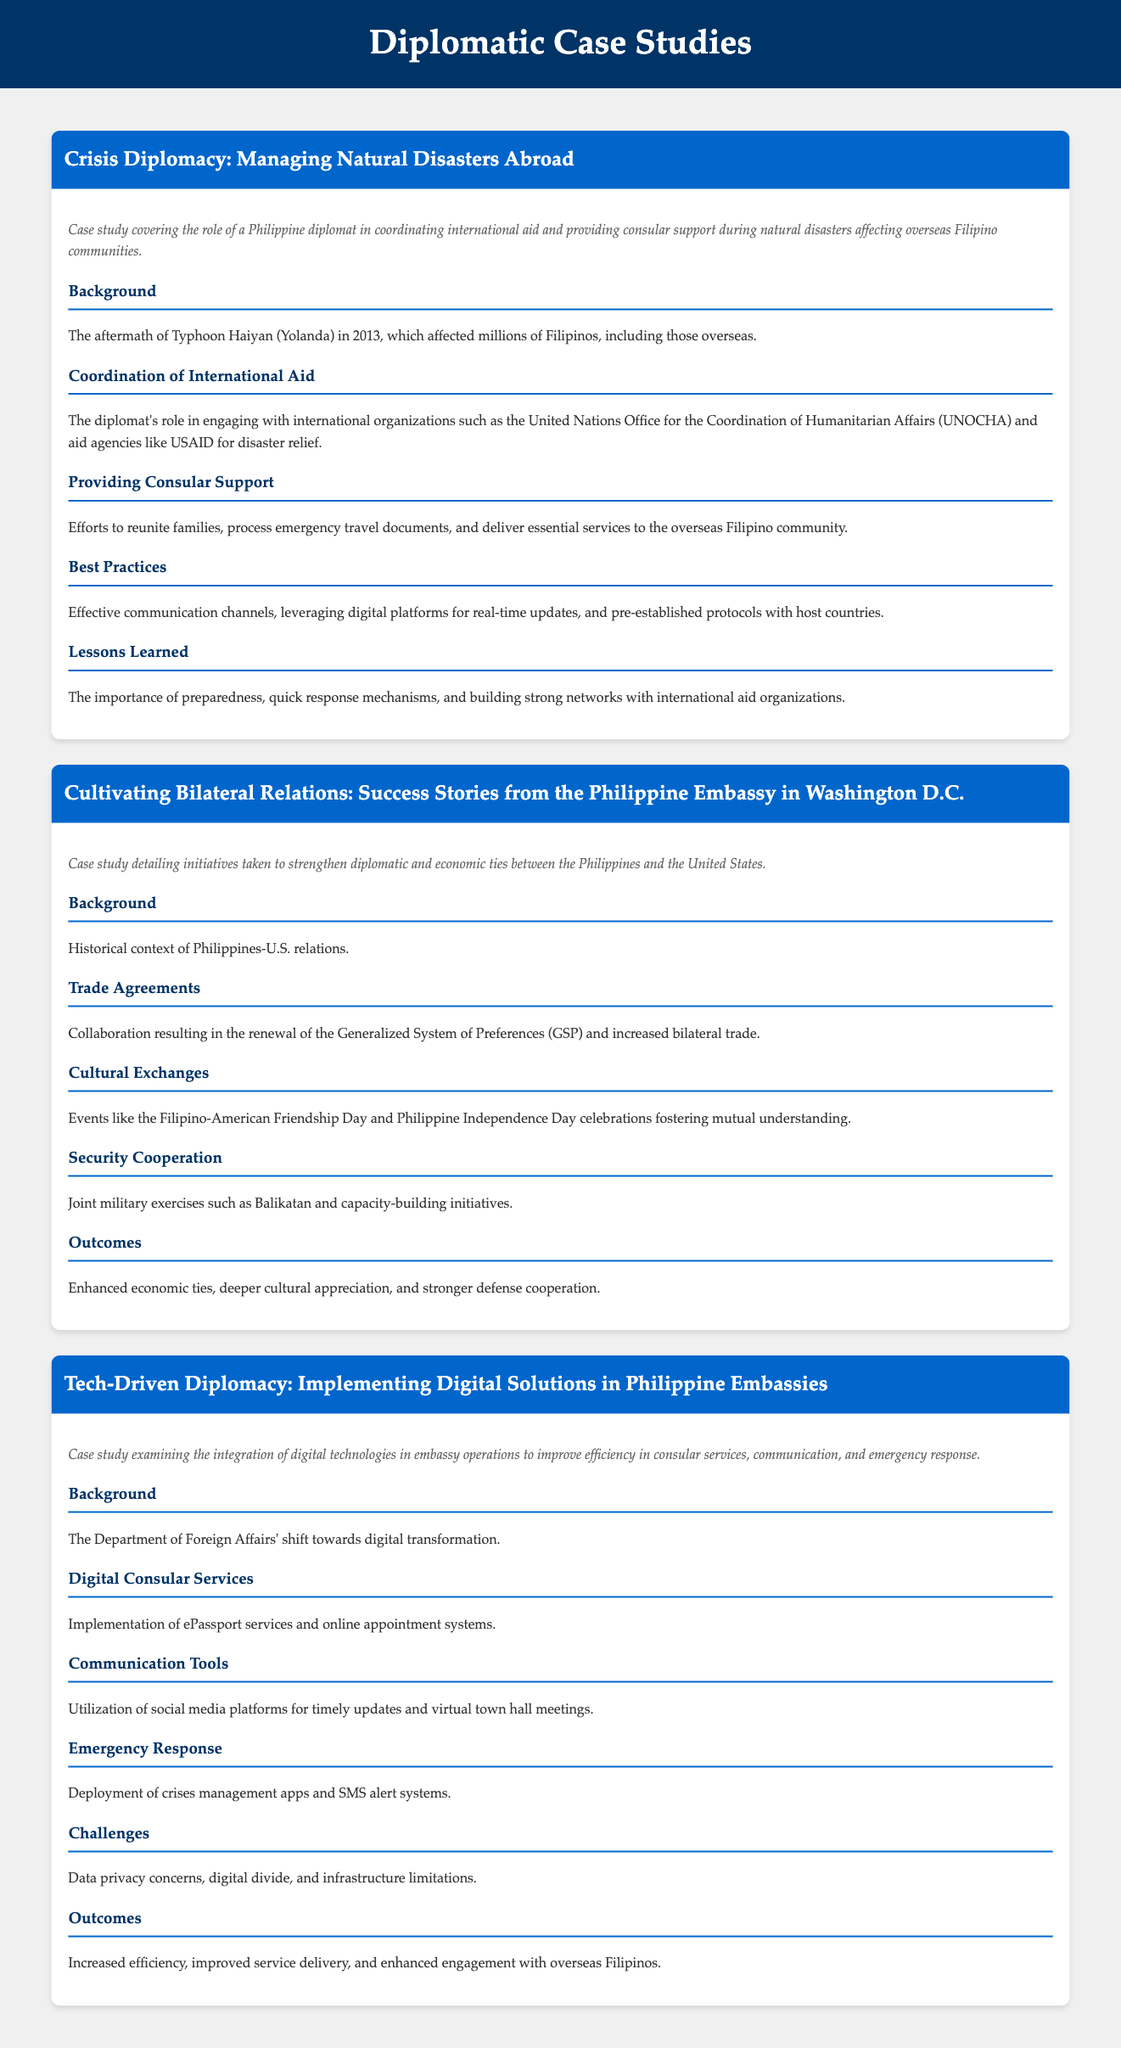what major disaster is highlighted in the first case study? The case study focuses on Typhoon Haiyan (Yolanda) which affected millions of Filipinos.
Answer: Typhoon Haiyan (Yolanda) which international organization did the diplomat engage with for disaster relief? The diplomat engaged with the United Nations Office for the Coordination of Humanitarian Affairs (UNOCHA).
Answer: UNOCHA what key initiative strengthened economic ties between the Philippines and the United States? The renewal of the Generalized System of Preferences (GSP) is a key initiative.
Answer: Generalized System of Preferences (GSP) what is a primary outcome of the cultural exchanges detailed in the second case study? The primary outcome is deeper cultural appreciation.
Answer: Deeper cultural appreciation what digital solution was implemented to enhance consular services? ePassport services were implemented as part of the digital solutions.
Answer: ePassport services what challenge is mentioned regarding the integration of digital technologies? Data privacy concerns are one of the challenges faced.
Answer: Data privacy concerns what is the purpose of the crises management apps discussed in the third case study? The purpose is to improve emergency response capabilities.
Answer: Improve emergency response capabilities 